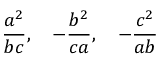<formula> <loc_0><loc_0><loc_500><loc_500>{ \frac { a ^ { 2 } } { b c } } , \quad - { \frac { b ^ { 2 } } { c a } } , \quad - { \frac { c ^ { 2 } } { a b } }</formula> 